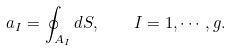Convert formula to latex. <formula><loc_0><loc_0><loc_500><loc_500>a _ { I } = \oint _ { A _ { I } } d S , \quad I = 1 , \cdots , g .</formula> 